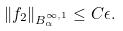<formula> <loc_0><loc_0><loc_500><loc_500>\| f _ { 2 } \| _ { B ^ { \infty , 1 } _ { \alpha } } \leq C \epsilon .</formula> 